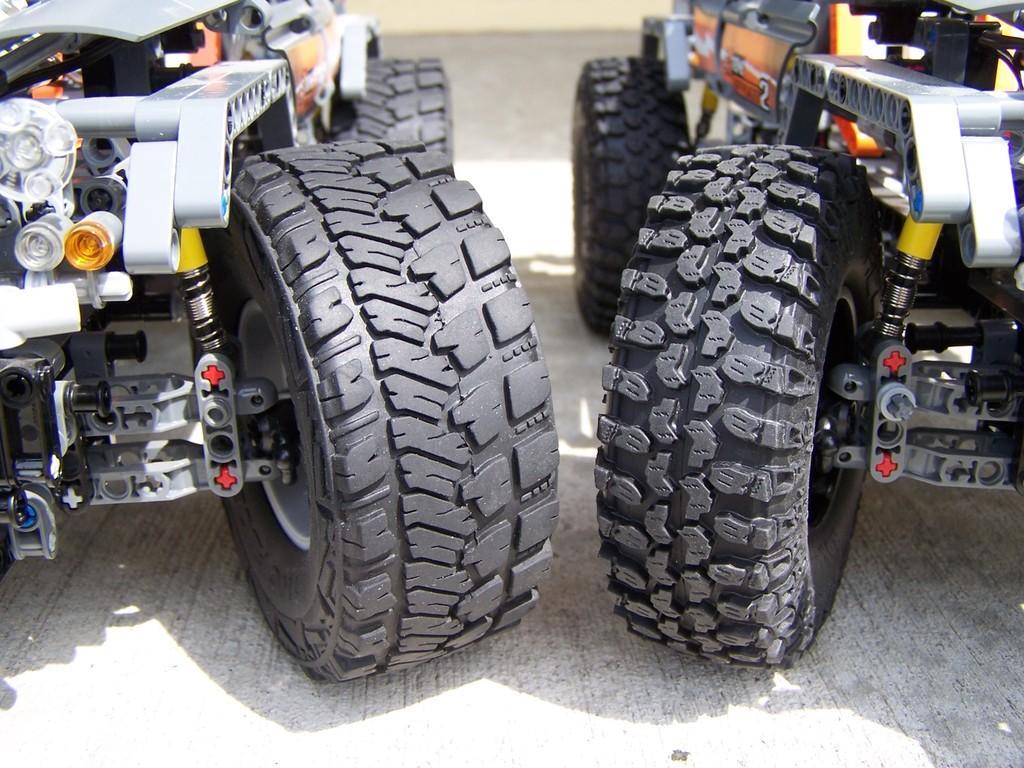How would you summarize this image in a sentence or two? Here I can see two toy cars on the floor. 